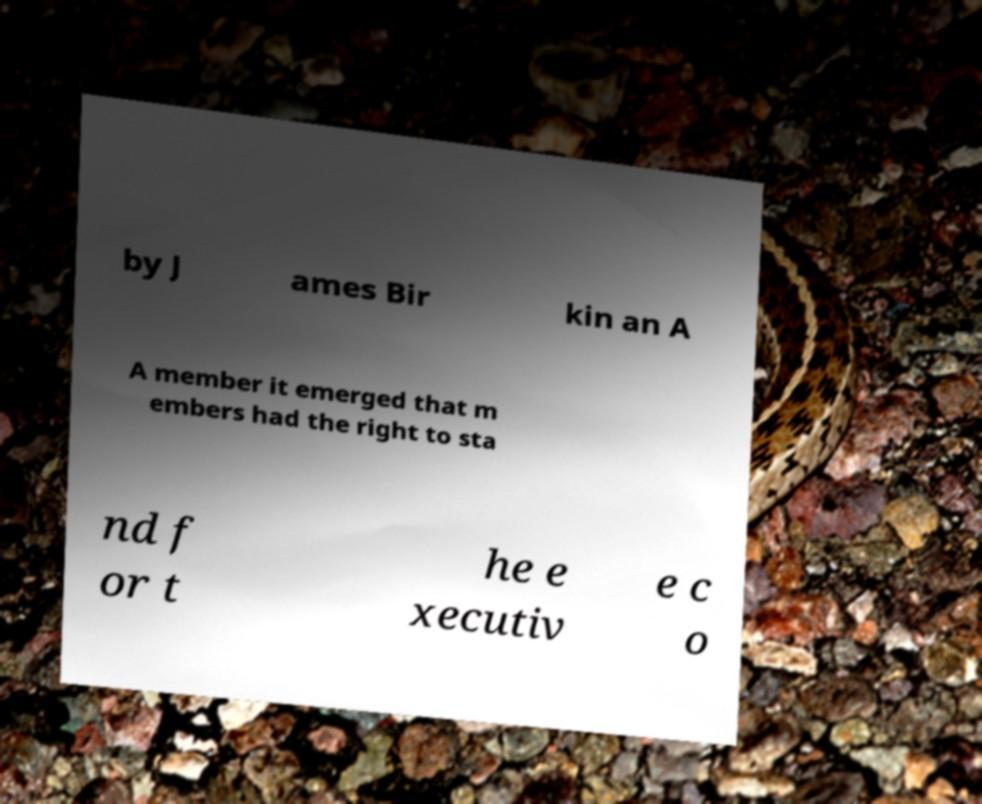Could you extract and type out the text from this image? by J ames Bir kin an A A member it emerged that m embers had the right to sta nd f or t he e xecutiv e c o 